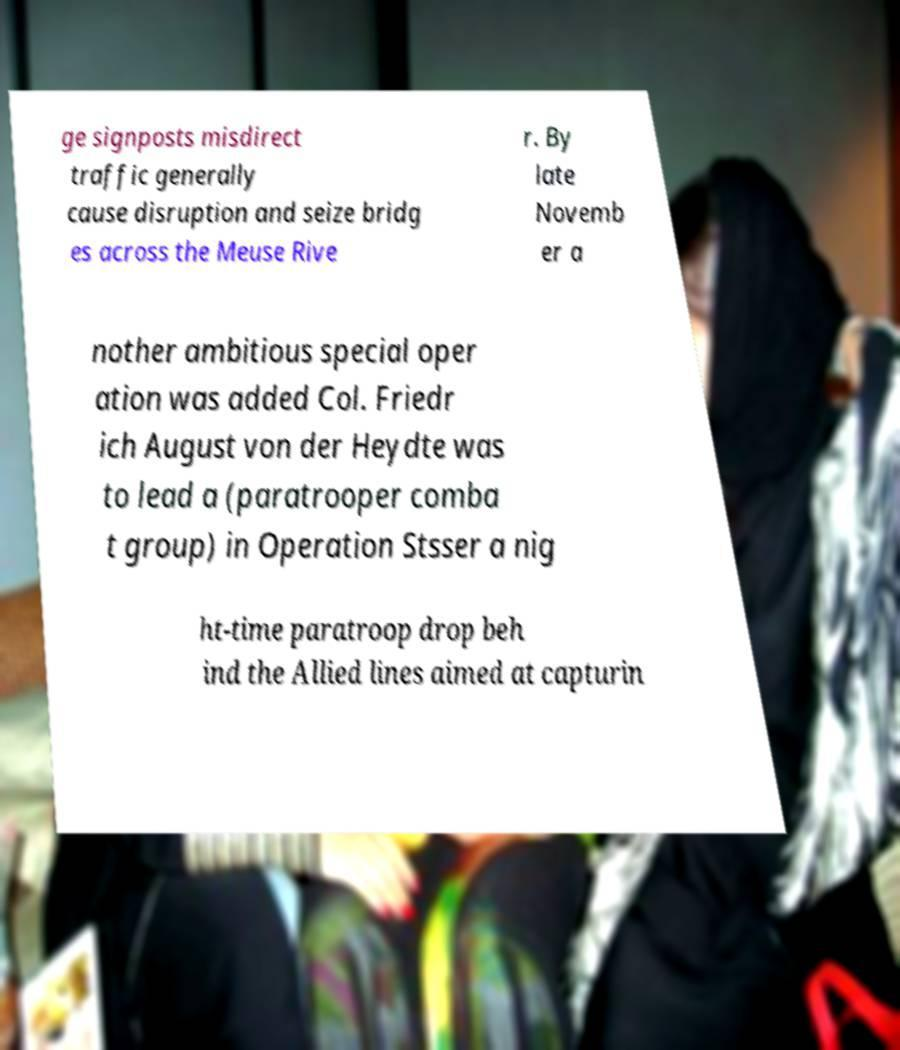I need the written content from this picture converted into text. Can you do that? ge signposts misdirect traffic generally cause disruption and seize bridg es across the Meuse Rive r. By late Novemb er a nother ambitious special oper ation was added Col. Friedr ich August von der Heydte was to lead a (paratrooper comba t group) in Operation Stsser a nig ht-time paratroop drop beh ind the Allied lines aimed at capturin 